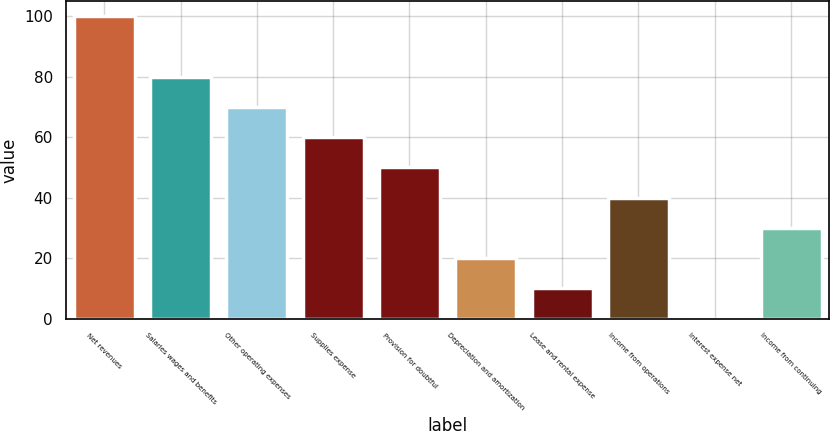Convert chart to OTSL. <chart><loc_0><loc_0><loc_500><loc_500><bar_chart><fcel>Net revenues<fcel>Salaries wages and benefits<fcel>Other operating expenses<fcel>Supplies expense<fcel>Provision for doubtful<fcel>Depreciation and amortization<fcel>Lease and rental expense<fcel>Income from operations<fcel>Interest expense net<fcel>Income from continuing<nl><fcel>100<fcel>80.02<fcel>70.03<fcel>60.04<fcel>50.05<fcel>20.08<fcel>10.09<fcel>40.06<fcel>0.1<fcel>30.07<nl></chart> 